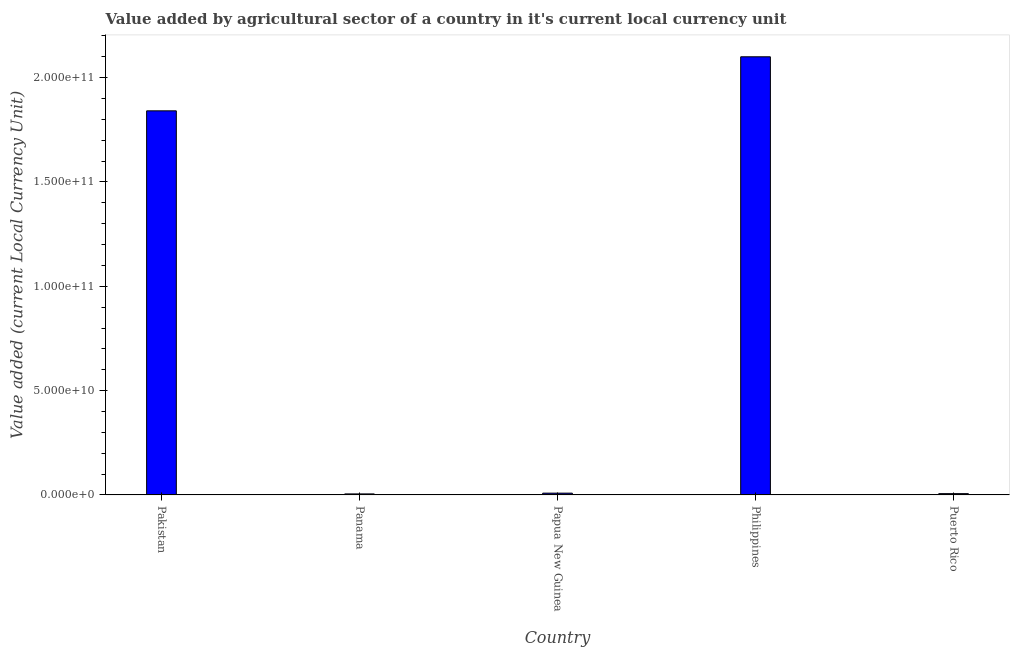Does the graph contain any zero values?
Your answer should be very brief. No. Does the graph contain grids?
Provide a short and direct response. No. What is the title of the graph?
Your answer should be very brief. Value added by agricultural sector of a country in it's current local currency unit. What is the label or title of the X-axis?
Offer a terse response. Country. What is the label or title of the Y-axis?
Your answer should be compact. Value added (current Local Currency Unit). What is the value added by agriculture sector in Papua New Guinea?
Offer a very short reply. 8.56e+08. Across all countries, what is the maximum value added by agriculture sector?
Ensure brevity in your answer.  2.10e+11. Across all countries, what is the minimum value added by agriculture sector?
Give a very brief answer. 4.88e+08. In which country was the value added by agriculture sector minimum?
Make the answer very short. Panama. What is the sum of the value added by agriculture sector?
Offer a very short reply. 3.96e+11. What is the difference between the value added by agriculture sector in Papua New Guinea and Puerto Rico?
Your answer should be very brief. 2.43e+08. What is the average value added by agriculture sector per country?
Keep it short and to the point. 7.92e+1. What is the median value added by agriculture sector?
Provide a succinct answer. 8.56e+08. What is the ratio of the value added by agriculture sector in Panama to that in Puerto Rico?
Your answer should be very brief. 0.8. Is the value added by agriculture sector in Papua New Guinea less than that in Puerto Rico?
Offer a very short reply. No. Is the difference between the value added by agriculture sector in Pakistan and Philippines greater than the difference between any two countries?
Provide a succinct answer. No. What is the difference between the highest and the second highest value added by agriculture sector?
Your answer should be compact. 2.59e+1. Is the sum of the value added by agriculture sector in Panama and Puerto Rico greater than the maximum value added by agriculture sector across all countries?
Offer a terse response. No. What is the difference between the highest and the lowest value added by agriculture sector?
Give a very brief answer. 2.10e+11. How many bars are there?
Give a very brief answer. 5. Are all the bars in the graph horizontal?
Provide a short and direct response. No. What is the difference between two consecutive major ticks on the Y-axis?
Offer a very short reply. 5.00e+1. Are the values on the major ticks of Y-axis written in scientific E-notation?
Keep it short and to the point. Yes. What is the Value added (current Local Currency Unit) of Pakistan?
Provide a short and direct response. 1.84e+11. What is the Value added (current Local Currency Unit) in Panama?
Provide a succinct answer. 4.88e+08. What is the Value added (current Local Currency Unit) of Papua New Guinea?
Offer a very short reply. 8.56e+08. What is the Value added (current Local Currency Unit) in Philippines?
Your response must be concise. 2.10e+11. What is the Value added (current Local Currency Unit) in Puerto Rico?
Offer a terse response. 6.13e+08. What is the difference between the Value added (current Local Currency Unit) in Pakistan and Panama?
Your answer should be compact. 1.84e+11. What is the difference between the Value added (current Local Currency Unit) in Pakistan and Papua New Guinea?
Your response must be concise. 1.83e+11. What is the difference between the Value added (current Local Currency Unit) in Pakistan and Philippines?
Offer a very short reply. -2.59e+1. What is the difference between the Value added (current Local Currency Unit) in Pakistan and Puerto Rico?
Your answer should be very brief. 1.83e+11. What is the difference between the Value added (current Local Currency Unit) in Panama and Papua New Guinea?
Provide a succinct answer. -3.68e+08. What is the difference between the Value added (current Local Currency Unit) in Panama and Philippines?
Keep it short and to the point. -2.10e+11. What is the difference between the Value added (current Local Currency Unit) in Panama and Puerto Rico?
Your answer should be very brief. -1.25e+08. What is the difference between the Value added (current Local Currency Unit) in Papua New Guinea and Philippines?
Your answer should be compact. -2.09e+11. What is the difference between the Value added (current Local Currency Unit) in Papua New Guinea and Puerto Rico?
Keep it short and to the point. 2.43e+08. What is the difference between the Value added (current Local Currency Unit) in Philippines and Puerto Rico?
Provide a short and direct response. 2.09e+11. What is the ratio of the Value added (current Local Currency Unit) in Pakistan to that in Panama?
Your response must be concise. 377.18. What is the ratio of the Value added (current Local Currency Unit) in Pakistan to that in Papua New Guinea?
Offer a very short reply. 215. What is the ratio of the Value added (current Local Currency Unit) in Pakistan to that in Philippines?
Provide a succinct answer. 0.88. What is the ratio of the Value added (current Local Currency Unit) in Pakistan to that in Puerto Rico?
Your answer should be compact. 300.1. What is the ratio of the Value added (current Local Currency Unit) in Panama to that in Papua New Guinea?
Provide a succinct answer. 0.57. What is the ratio of the Value added (current Local Currency Unit) in Panama to that in Philippines?
Give a very brief answer. 0. What is the ratio of the Value added (current Local Currency Unit) in Panama to that in Puerto Rico?
Your response must be concise. 0.8. What is the ratio of the Value added (current Local Currency Unit) in Papua New Guinea to that in Philippines?
Provide a short and direct response. 0. What is the ratio of the Value added (current Local Currency Unit) in Papua New Guinea to that in Puerto Rico?
Provide a succinct answer. 1.4. What is the ratio of the Value added (current Local Currency Unit) in Philippines to that in Puerto Rico?
Your response must be concise. 342.34. 